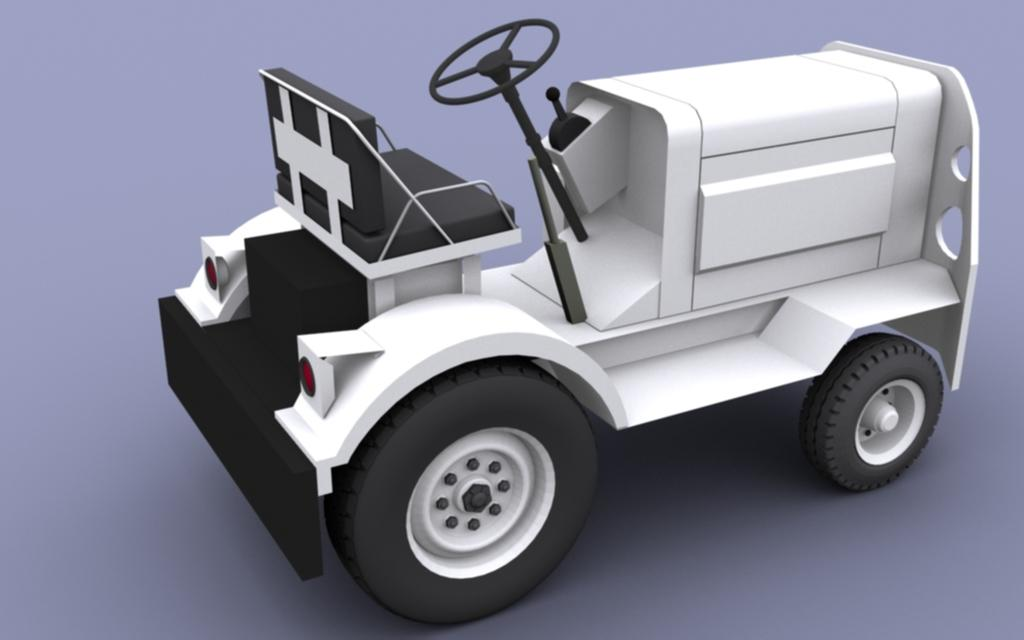What is the main subject of the image? There is a depiction of a vehicle in the image. What type of invention does the fireman use to put out the fire in the image? There is no fireman or fire present in the image; it only features a depiction of a vehicle. 